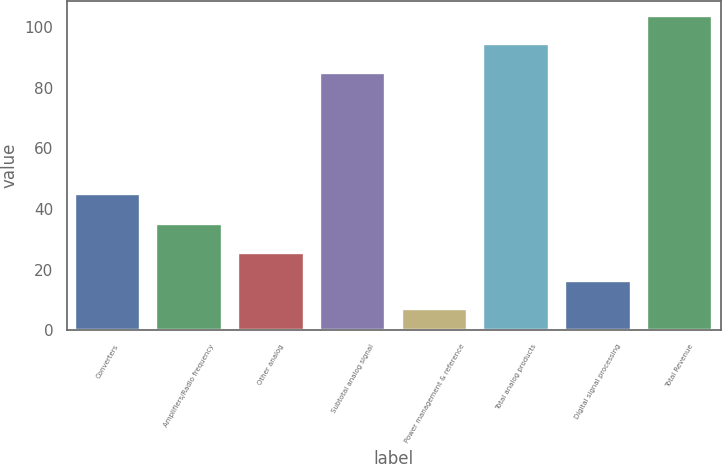<chart> <loc_0><loc_0><loc_500><loc_500><bar_chart><fcel>Converters<fcel>Amplifiers/Radio frequency<fcel>Other analog<fcel>Subtotal analog signal<fcel>Power management & reference<fcel>Total analog products<fcel>Digital signal processing<fcel>Total Revenue<nl><fcel>45<fcel>34.9<fcel>25.6<fcel>85<fcel>7<fcel>94.3<fcel>16.3<fcel>103.6<nl></chart> 